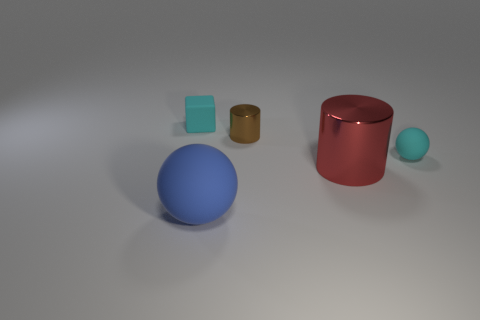There is a cyan thing that is the same material as the tiny ball; what size is it?
Offer a terse response. Small. What number of tiny metallic objects are the same shape as the big red shiny thing?
Keep it short and to the point. 1. Are there more tiny cyan matte objects on the right side of the big red shiny object than large purple matte cylinders?
Ensure brevity in your answer.  Yes. What shape is the tiny object that is left of the big cylinder and in front of the small cube?
Keep it short and to the point. Cylinder. Do the red cylinder and the brown shiny object have the same size?
Give a very brief answer. No. What number of brown objects are on the left side of the tiny brown cylinder?
Give a very brief answer. 0. Is the number of metallic things behind the cyan matte block the same as the number of big cylinders to the left of the large cylinder?
Make the answer very short. Yes. There is a metal object to the right of the small metal cylinder; is it the same shape as the small shiny object?
Make the answer very short. Yes. There is a brown metal object; is its size the same as the matte object right of the brown thing?
Your response must be concise. Yes. What number of other things are there of the same color as the matte cube?
Provide a short and direct response. 1. 